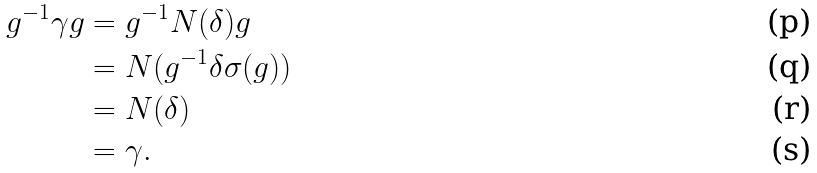<formula> <loc_0><loc_0><loc_500><loc_500>g ^ { - 1 } \gamma g & = g ^ { - 1 } N ( \delta ) g \\ & = N ( g ^ { - 1 } \delta \sigma ( g ) ) \\ & = N ( \delta ) \\ & = \gamma .</formula> 